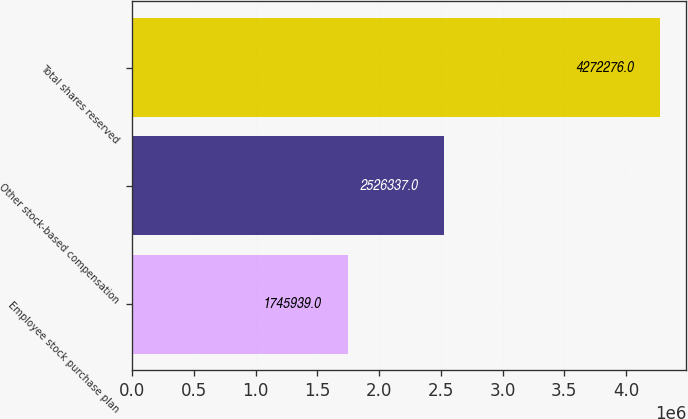Convert chart to OTSL. <chart><loc_0><loc_0><loc_500><loc_500><bar_chart><fcel>Employee stock purchase plan<fcel>Other stock-based compensation<fcel>Total shares reserved<nl><fcel>1.74594e+06<fcel>2.52634e+06<fcel>4.27228e+06<nl></chart> 